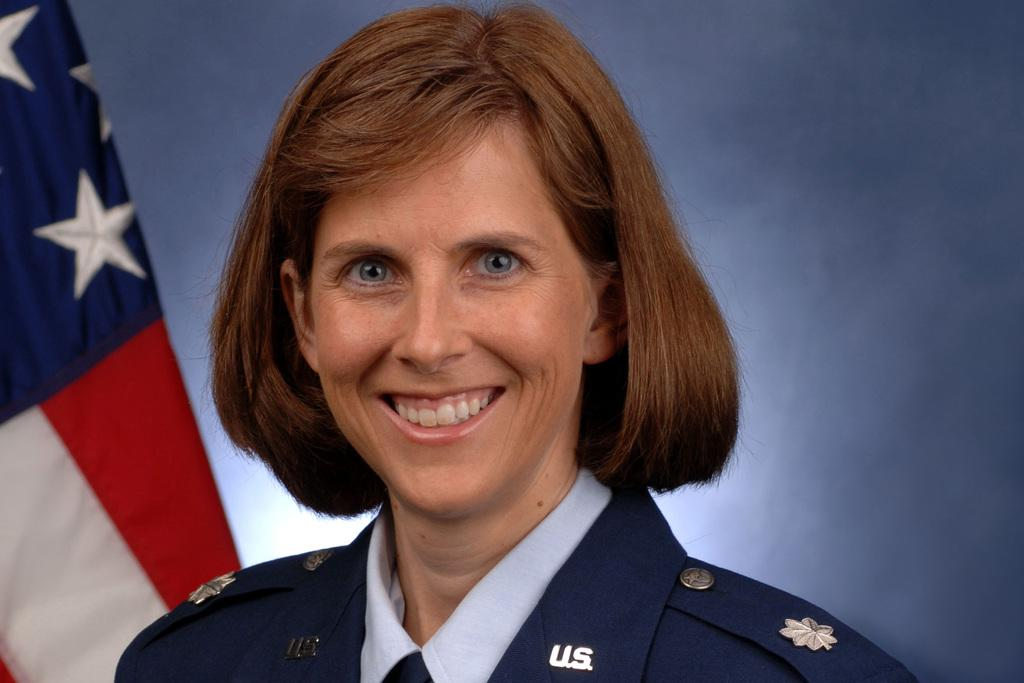What is the person in the image wearing? There is a person with a uniform in the image. What can be seen in the background of the image? There is a flag in the background of the image. What color is the background of the image? The background of the image is blue. How does the person in the image adjust the paste on their uniform? There is no mention of paste or any adjustment in the image; the person is simply wearing a uniform. 